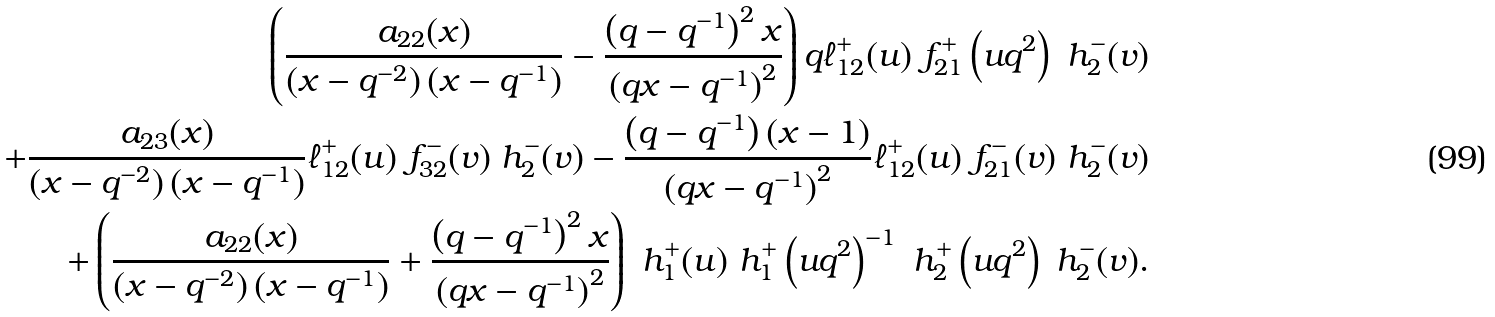<formula> <loc_0><loc_0><loc_500><loc_500>\left ( \frac { a _ { 2 2 } ( x ) } { \left ( x - q ^ { - 2 } \right ) \left ( x - q ^ { - 1 } \right ) } - \frac { \left ( q - q ^ { - 1 } \right ) ^ { 2 } x } { \left ( q x - q ^ { - 1 } \right ) ^ { 2 } } \right ) q \ell _ { 1 2 } ^ { + } ( u ) \ f _ { 2 1 } ^ { + } \left ( u q ^ { 2 } \right ) \ h _ { 2 } ^ { - } ( v ) \\ + \frac { a _ { 2 3 } ( x ) } { \left ( x - q ^ { - 2 } \right ) \left ( x - q ^ { - 1 } \right ) } \ell _ { 1 2 } ^ { + } ( u ) \ f _ { 3 2 } ^ { - } ( v ) \ h _ { 2 } ^ { - } ( v ) - \frac { \left ( q - q ^ { - 1 } \right ) ( x - 1 ) } { \left ( q x - q ^ { - 1 } \right ) ^ { 2 } } \ell ^ { + } _ { 1 2 } ( u ) \ f ^ { - } _ { 2 1 } ( v ) \ h ^ { - } _ { 2 } ( v ) \\ + \left ( \frac { a _ { 2 2 } ( x ) } { \left ( x - q ^ { - 2 } \right ) \left ( x - q ^ { - 1 } \right ) } + \frac { \left ( q - q ^ { - 1 } \right ) ^ { 2 } x } { \left ( q x - q ^ { - 1 } \right ) ^ { 2 } } \right ) \ h _ { 1 } ^ { + } ( u ) \ h _ { 1 } ^ { + } \left ( u q ^ { 2 } \right ) ^ { - 1 } \ h _ { 2 } ^ { + } \left ( u q ^ { 2 } \right ) \ h _ { 2 } ^ { - } ( v ) .</formula> 